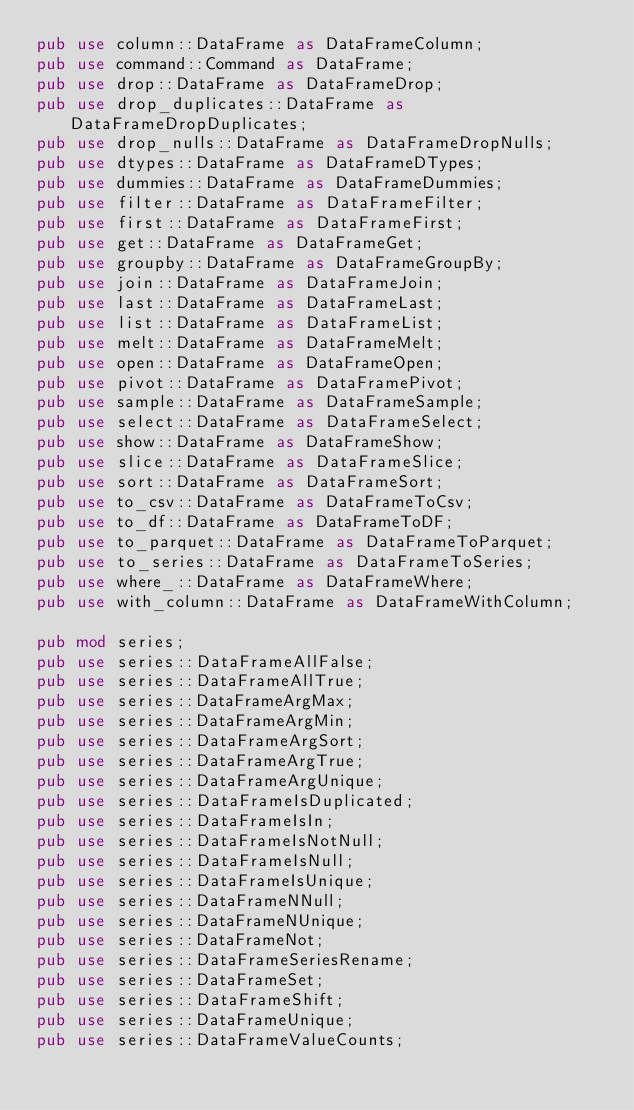<code> <loc_0><loc_0><loc_500><loc_500><_Rust_>pub use column::DataFrame as DataFrameColumn;
pub use command::Command as DataFrame;
pub use drop::DataFrame as DataFrameDrop;
pub use drop_duplicates::DataFrame as DataFrameDropDuplicates;
pub use drop_nulls::DataFrame as DataFrameDropNulls;
pub use dtypes::DataFrame as DataFrameDTypes;
pub use dummies::DataFrame as DataFrameDummies;
pub use filter::DataFrame as DataFrameFilter;
pub use first::DataFrame as DataFrameFirst;
pub use get::DataFrame as DataFrameGet;
pub use groupby::DataFrame as DataFrameGroupBy;
pub use join::DataFrame as DataFrameJoin;
pub use last::DataFrame as DataFrameLast;
pub use list::DataFrame as DataFrameList;
pub use melt::DataFrame as DataFrameMelt;
pub use open::DataFrame as DataFrameOpen;
pub use pivot::DataFrame as DataFramePivot;
pub use sample::DataFrame as DataFrameSample;
pub use select::DataFrame as DataFrameSelect;
pub use show::DataFrame as DataFrameShow;
pub use slice::DataFrame as DataFrameSlice;
pub use sort::DataFrame as DataFrameSort;
pub use to_csv::DataFrame as DataFrameToCsv;
pub use to_df::DataFrame as DataFrameToDF;
pub use to_parquet::DataFrame as DataFrameToParquet;
pub use to_series::DataFrame as DataFrameToSeries;
pub use where_::DataFrame as DataFrameWhere;
pub use with_column::DataFrame as DataFrameWithColumn;

pub mod series;
pub use series::DataFrameAllFalse;
pub use series::DataFrameAllTrue;
pub use series::DataFrameArgMax;
pub use series::DataFrameArgMin;
pub use series::DataFrameArgSort;
pub use series::DataFrameArgTrue;
pub use series::DataFrameArgUnique;
pub use series::DataFrameIsDuplicated;
pub use series::DataFrameIsIn;
pub use series::DataFrameIsNotNull;
pub use series::DataFrameIsNull;
pub use series::DataFrameIsUnique;
pub use series::DataFrameNNull;
pub use series::DataFrameNUnique;
pub use series::DataFrameNot;
pub use series::DataFrameSeriesRename;
pub use series::DataFrameSet;
pub use series::DataFrameShift;
pub use series::DataFrameUnique;
pub use series::DataFrameValueCounts;
</code> 